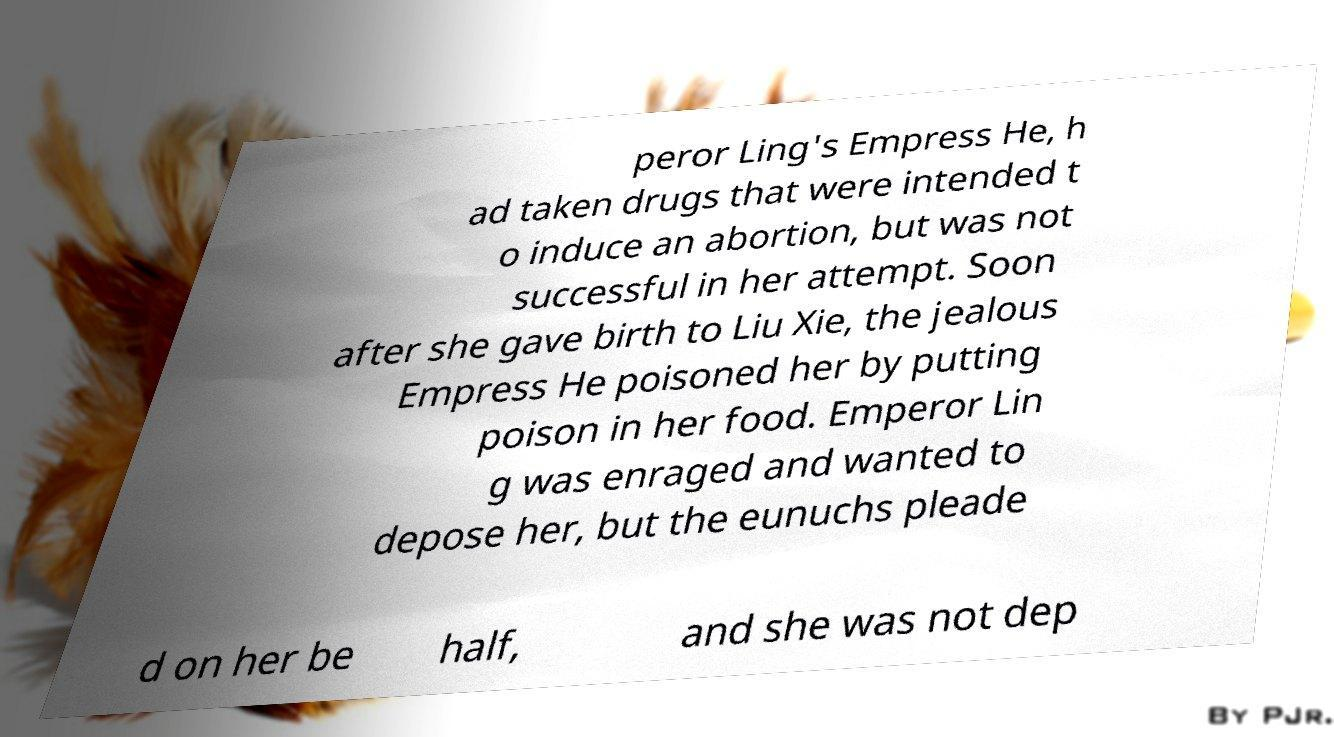Please identify and transcribe the text found in this image. peror Ling's Empress He, h ad taken drugs that were intended t o induce an abortion, but was not successful in her attempt. Soon after she gave birth to Liu Xie, the jealous Empress He poisoned her by putting poison in her food. Emperor Lin g was enraged and wanted to depose her, but the eunuchs pleade d on her be half, and she was not dep 